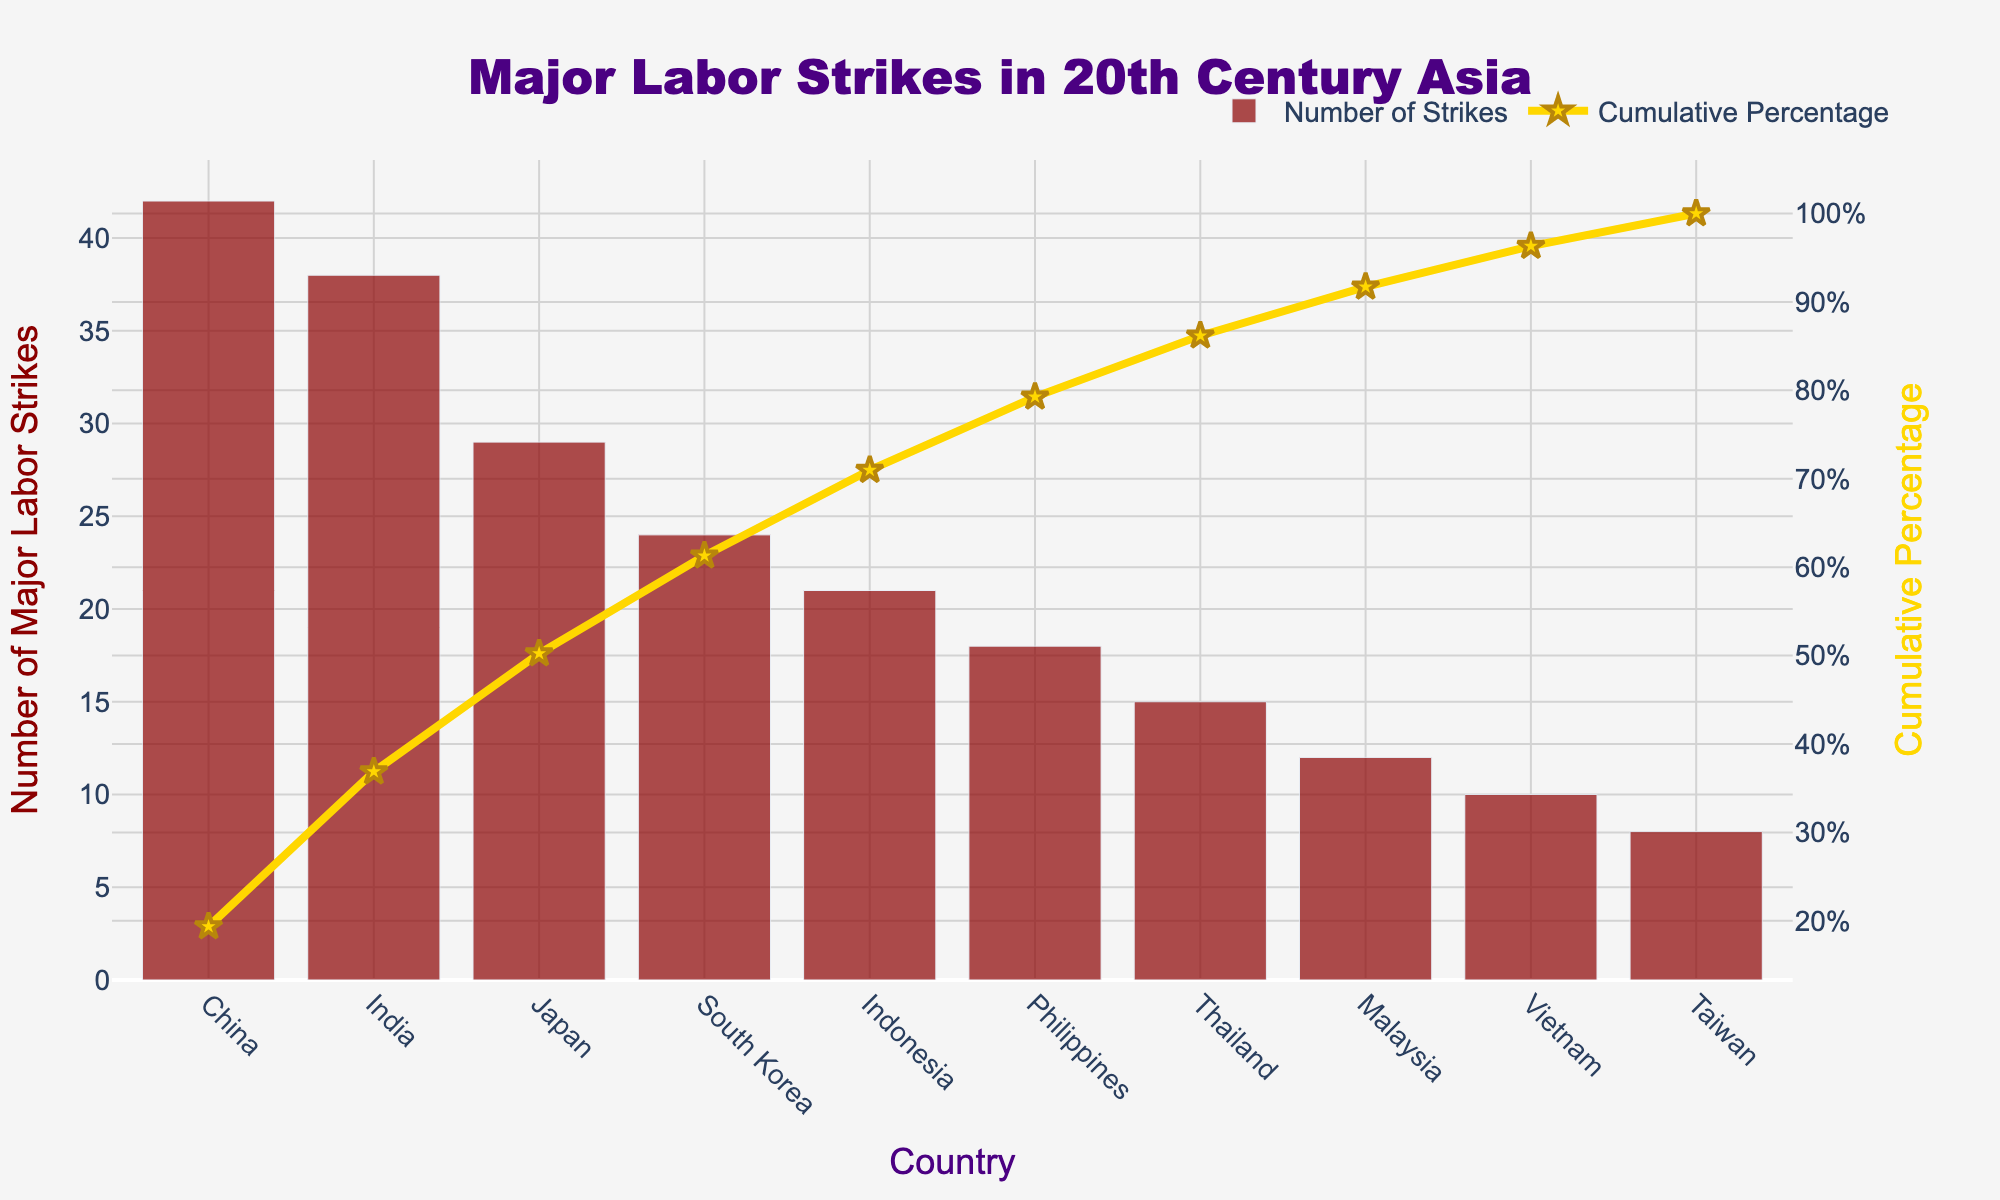What is the title of the chart? The title of the chart is usually displayed at the top of the figure. In this case, it is "Major Labor Strikes in 20th Century Asia".
Answer: Major Labor Strikes in 20th Century Asia Which country had the highest number of major labor strikes? Look at the bar chart and identify the highest bar. The country with the highest bar represents the highest number of strikes.
Answer: China What is the cumulative percentage for India? Find the point on the scatter plot (or line chart) that corresponds to India and look at its y-axis value on the right side (the cumulative percentage axis).
Answer: Approximately 50% How many major labor strikes are there in Japan? Find Japan on the x-axis and look at the height of its corresponding bar to see its value.
Answer: 29 Which two countries combined account for approximately 75% of all major labor strikes? Look at the cumulative percentage line and identify the countries that add up to around 75% when combined.
Answer: China and India What is the total number of major labor strikes for the top three countries? Add the values of the top three bars (China, India, and Japan). 42 + 38 + 29 = 109.
Answer: 109 Which country, among Malaysia and Thailand, experienced more major labor strikes? Compare the heights of the bars for Malaysia and Thailand and see which one is taller.
Answer: Thailand What is the color of the bars representing the number of major labor strikes? Observe the bars on the chart to determine their color.
Answer: Dark Red By what percentage does the cumulative percentage increase after including Indonesia? Calculate the difference in cumulative percentage before and after Indonesia. Sum of strikes before Indonesia: China (42) + India (38) + Japan (29) + South Korea (24) = 133. Indonesia brings the total to 154. Cumulative percentage for South Korea is around 76% and after Indonesia (21/197) + previous 76% = 86%. The increase is approximately 10%.
Answer: Approximately 10% How does the number of major labor strikes in Vietnam compare to those in Taiwan? Compare the heights of the bars for Vietnam and Taiwan to determine which one is higher or if they are equal.
Answer: Vietnam has more strikes than Taiwan 